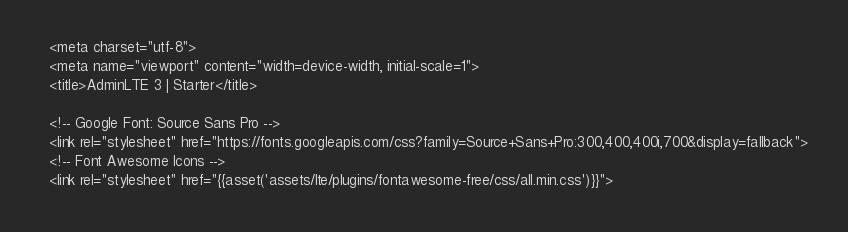<code> <loc_0><loc_0><loc_500><loc_500><_PHP_>  <meta charset="utf-8">
  <meta name="viewport" content="width=device-width, initial-scale=1">
  <title>AdminLTE 3 | Starter</title>

  <!-- Google Font: Source Sans Pro -->
  <link rel="stylesheet" href="https://fonts.googleapis.com/css?family=Source+Sans+Pro:300,400,400i,700&display=fallback">
  <!-- Font Awesome Icons -->
  <link rel="stylesheet" href="{{asset('assets/lte/plugins/fontawesome-free/css/all.min.css')}}">
</code> 